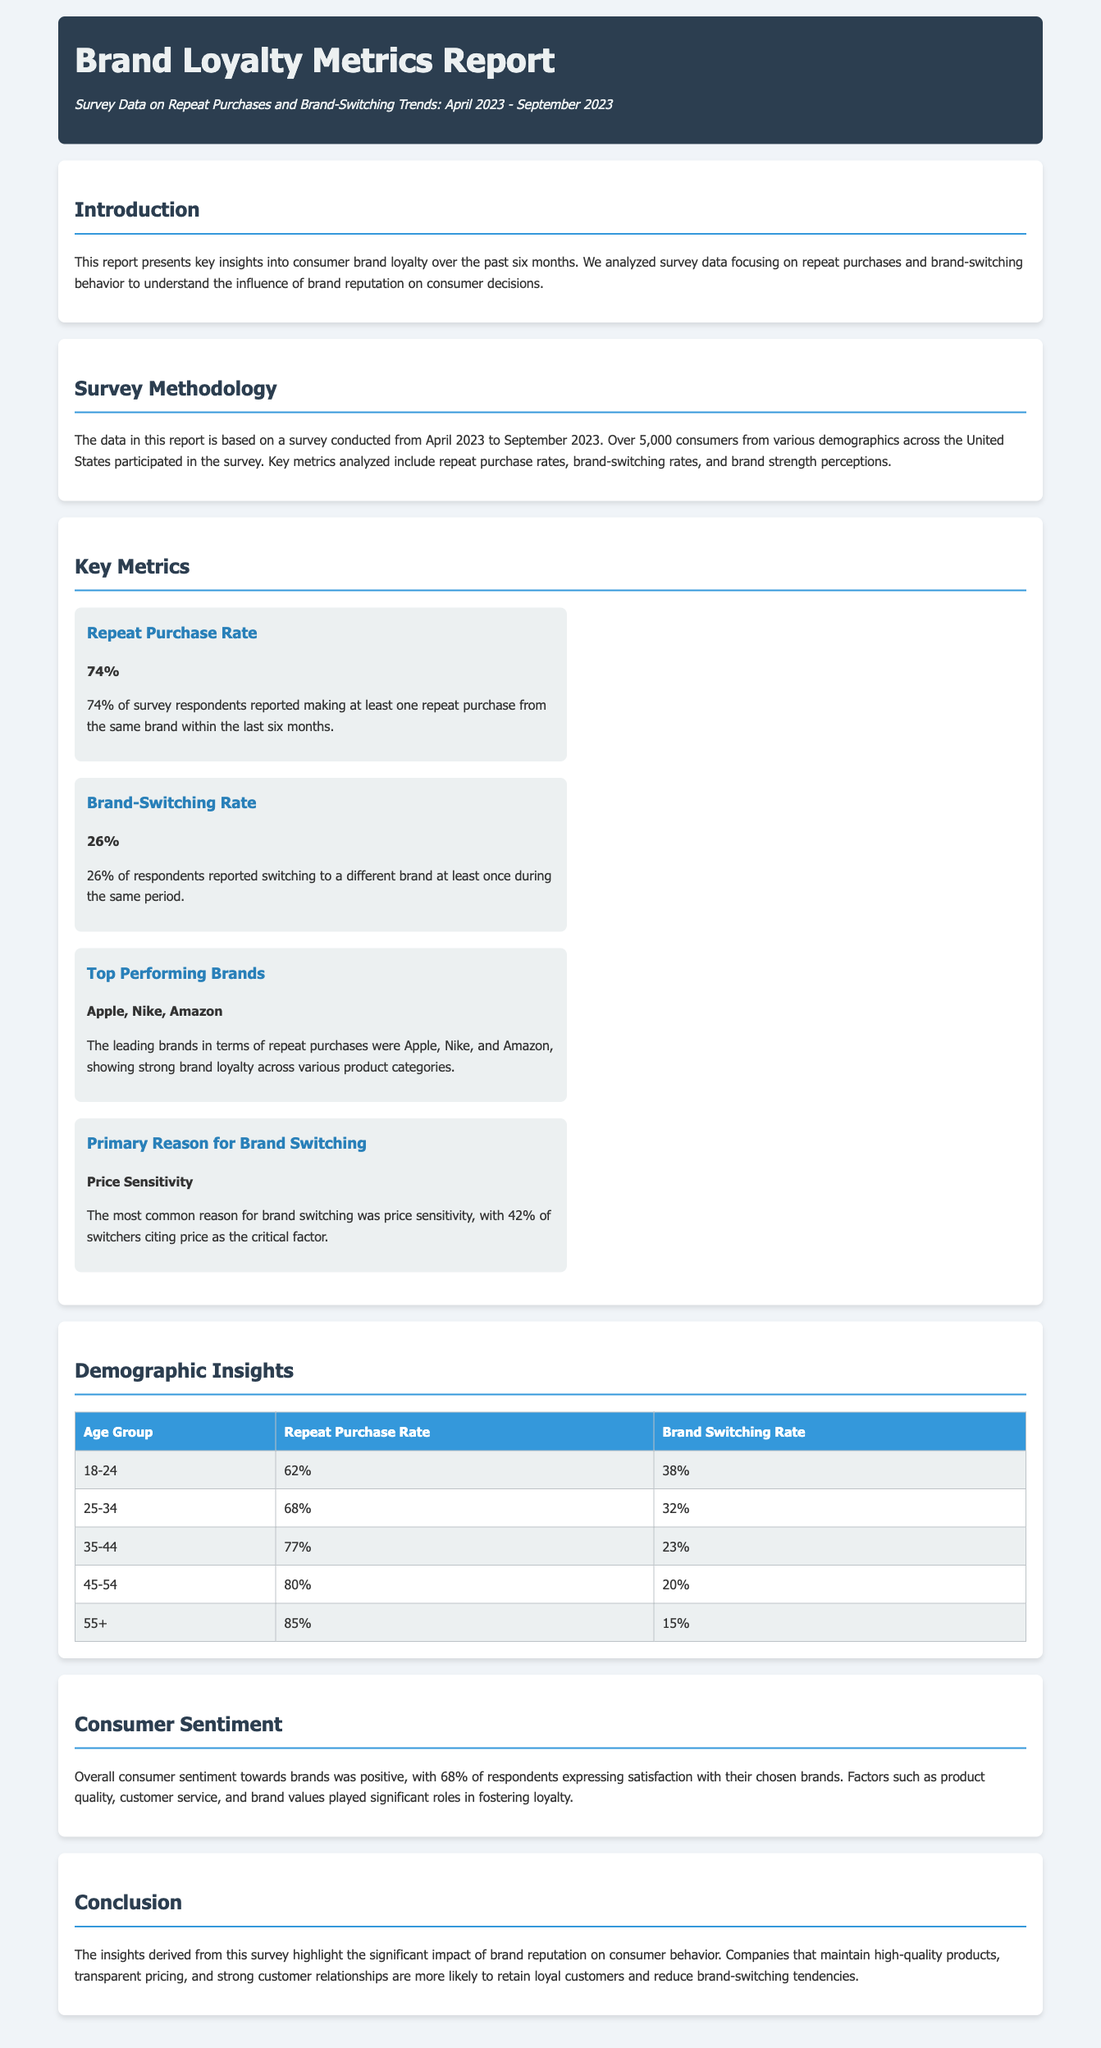what is the repeat purchase rate? The repeat purchase rate is the percentage of respondents who reported making at least one repeat purchase within the last six months, which is 74%.
Answer: 74% what percentage of respondents reported switching brands? This percentage indicates how many respondents switched to another brand at least once during the same period, which is 26%.
Answer: 26% which brands were identified as the top performers? The leading brands were identified based on repeat purchases, which are Apple, Nike, and Amazon.
Answer: Apple, Nike, Amazon what is the primary reason for brand switching? The primary reason for brand switching reported by consumers is price sensitivity, which was cited by 42% of switchers.
Answer: Price Sensitivity what is the repeat purchase rate for the age group 55+? This rate shows the repeat purchase behavior of older consumers, which is 85%.
Answer: 85% what demographic group has the highest brand switching rate? This group identifies the consumers who switch brands the most, which is the 18-24 age group at 38%.
Answer: 18-24 how many respondents expressed satisfaction with their chosen brands? This figure indicates the overall consumer sentiment towards their selected brands, which is 68%.
Answer: 68% what role do factors such as product quality and customer service play? These factors are mentioned as significant contributors to fostering brand loyalty among consumers.
Answer: Significant roles what was the duration of the survey conducted? The duration reflects the time frame within which the survey data was collected, from April 2023 to September 2023.
Answer: April 2023 - September 2023 